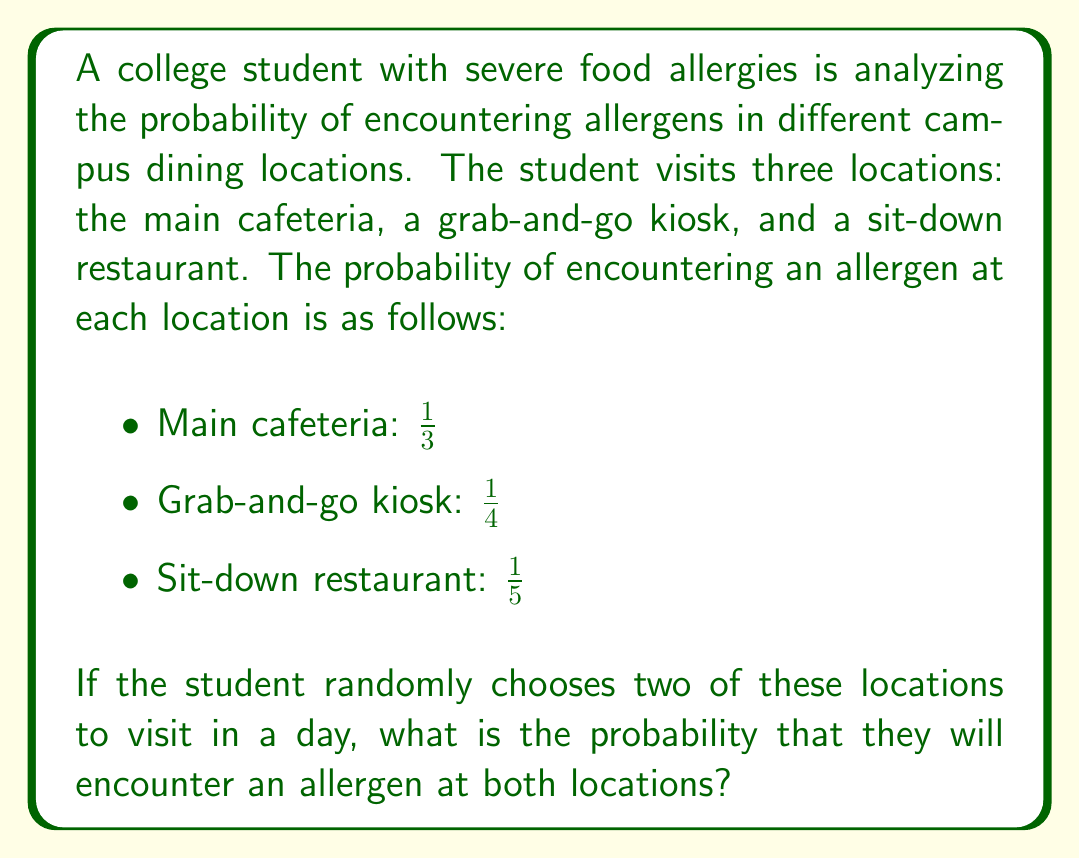Give your solution to this math problem. To solve this problem, we need to follow these steps:

1) First, we need to calculate the probability of choosing any two locations out of the three. This is a combination problem, and the number of ways to choose 2 out of 3 is:

   $${3 \choose 2} = \frac{3!}{2!(3-2)!} = \frac{3 \cdot 2}{2 \cdot 1} = 3$$

2) Now, we need to calculate the probability of encountering an allergen at both chosen locations for each possible combination:

   a) Main cafeteria and Grab-and-go kiosk: 
      $P(A) = \frac{1}{3} \cdot \frac{1}{4} = \frac{1}{12}$

   b) Main cafeteria and Sit-down restaurant:
      $P(B) = \frac{1}{3} \cdot \frac{1}{5} = \frac{1}{15}$

   c) Grab-and-go kiosk and Sit-down restaurant:
      $P(C) = \frac{1}{4} \cdot \frac{1}{5} = \frac{1}{20}$

3) The total probability is the sum of these individual probabilities:

   $$P(\text{allergen at both}) = P(A) + P(B) + P(C)$$
   $$= \frac{1}{12} + \frac{1}{15} + \frac{1}{20}$$

4) To add these fractions, we need a common denominator. The least common multiple of 12, 15, and 20 is 60:

   $$= \frac{5}{60} + \frac{4}{60} + \frac{3}{60} = \frac{12}{60} = \frac{1}{5}$$

Thus, the probability of encountering an allergen at both randomly chosen locations is $\frac{1}{5}$ or 0.2 or 20%.
Answer: $\frac{1}{5}$ or 0.2 or 20% 